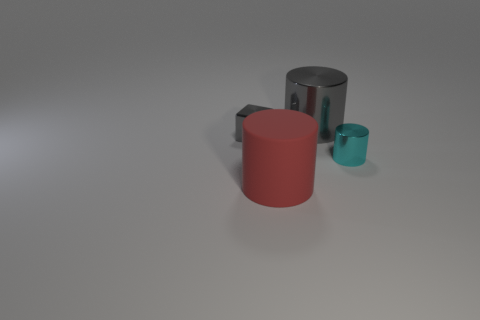Is there a function these objects might serve together, or do they seem unrelated? Based on the image, the objects seem unrelated as they do not appear to be designed to interact with or complement each other in a specific function. They're likely chosen to portray a contrast in size, color, and material for illustrative or artistic purposes. 